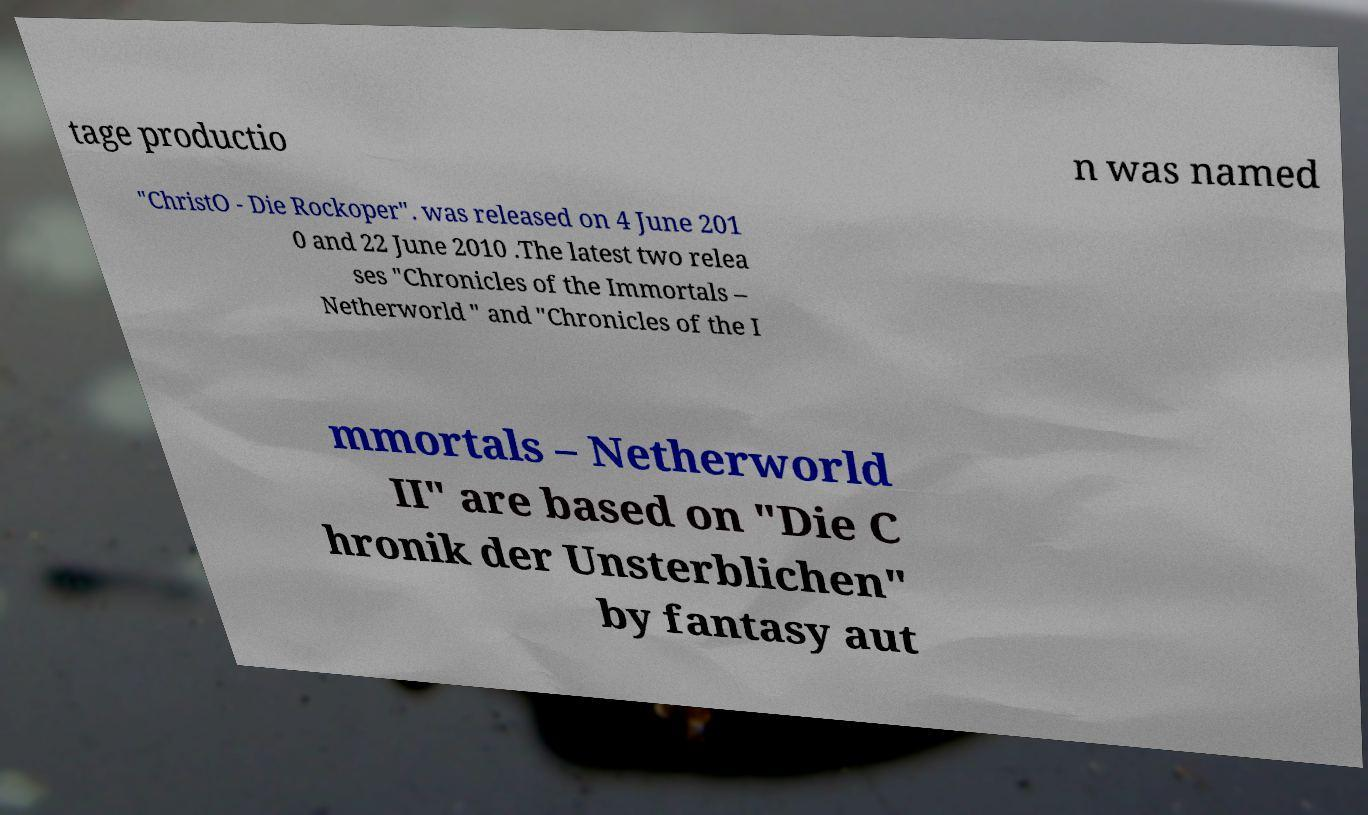Please read and relay the text visible in this image. What does it say? tage productio n was named "ChristO - Die Rockoper". was released on 4 June 201 0 and 22 June 2010 .The latest two relea ses "Chronicles of the Immortals – Netherworld " and "Chronicles of the I mmortals – Netherworld II" are based on "Die C hronik der Unsterblichen" by fantasy aut 